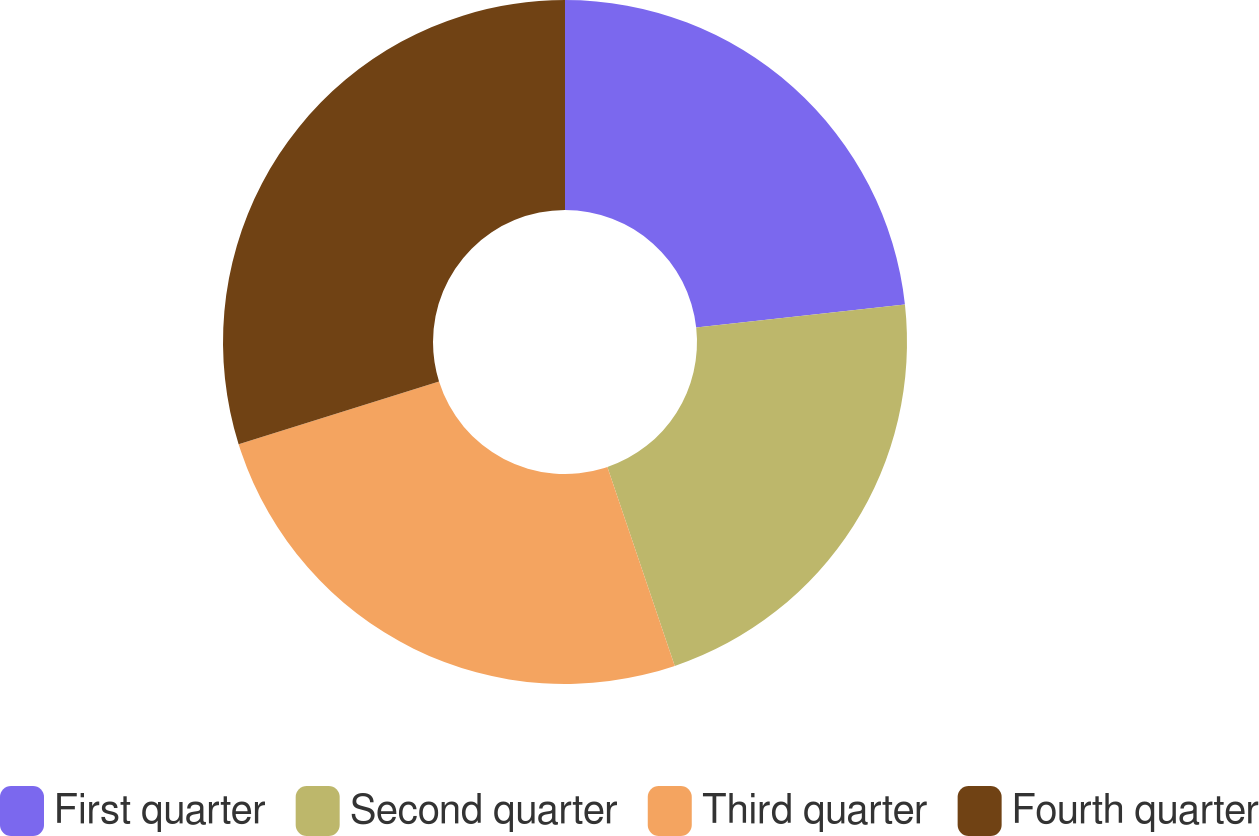Convert chart. <chart><loc_0><loc_0><loc_500><loc_500><pie_chart><fcel>First quarter<fcel>Second quarter<fcel>Third quarter<fcel>Fourth quarter<nl><fcel>23.25%<fcel>21.55%<fcel>25.37%<fcel>29.83%<nl></chart> 